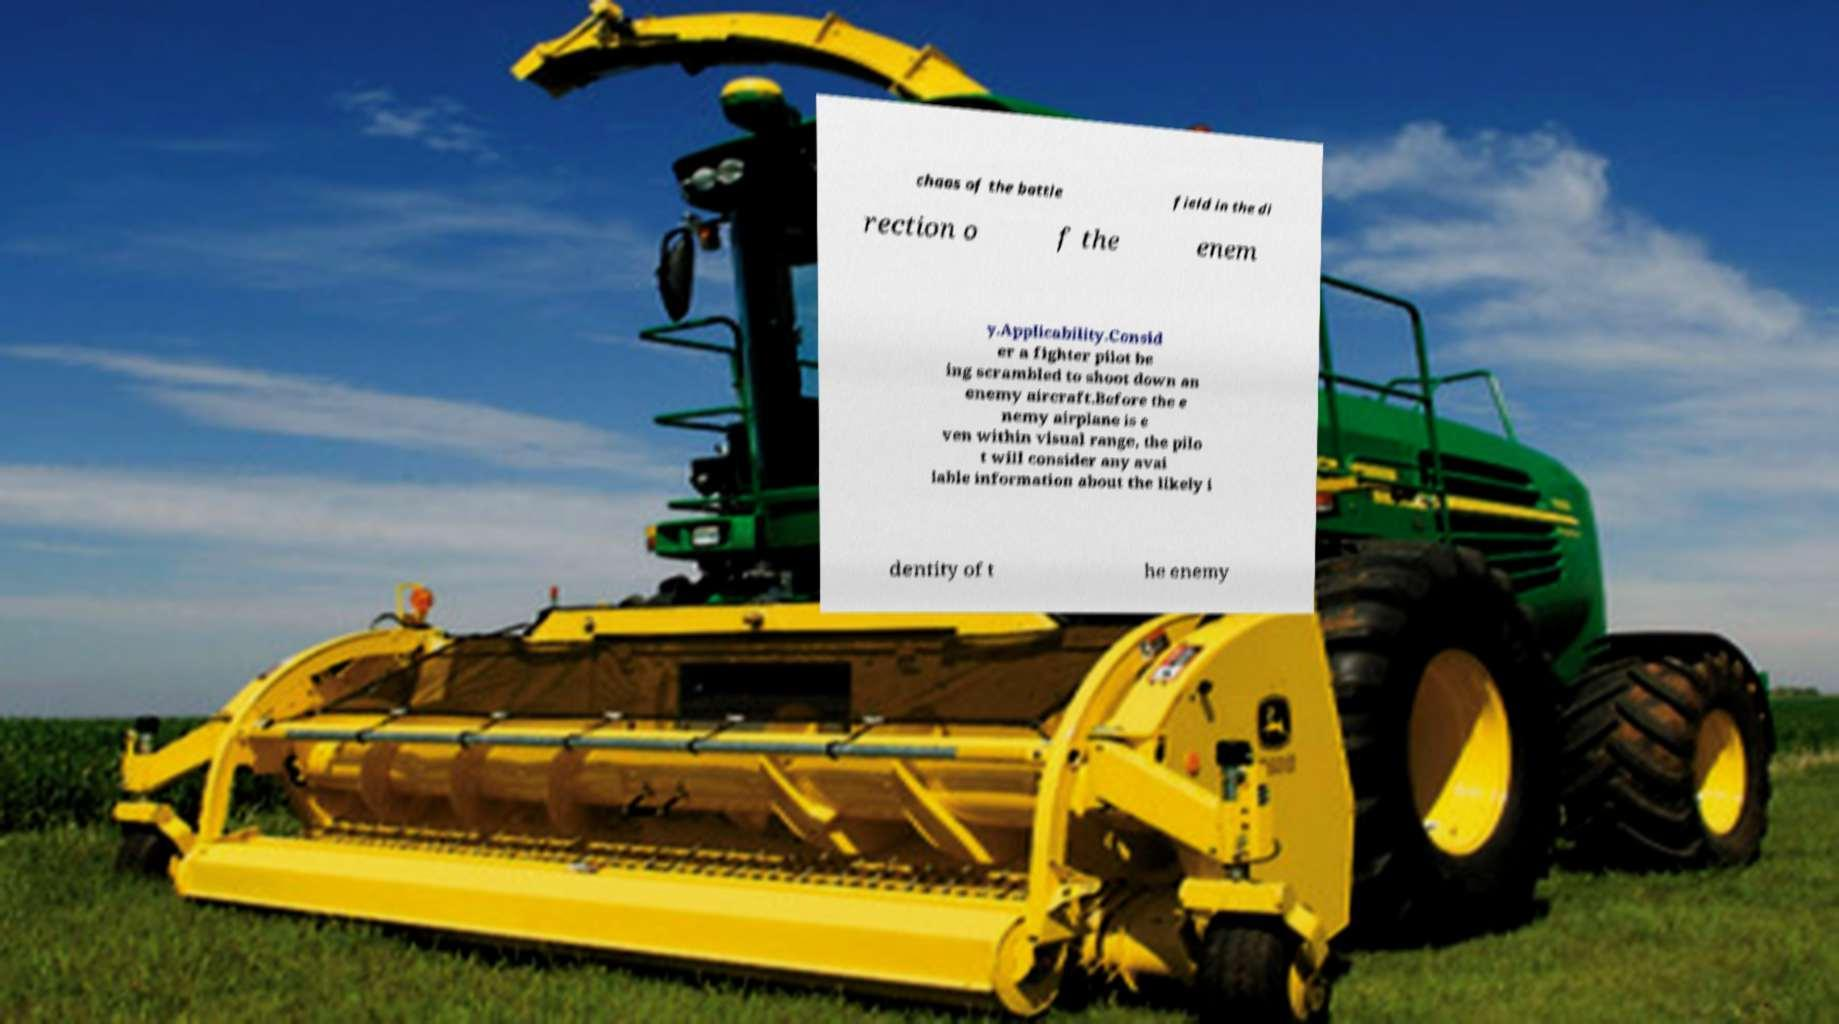For documentation purposes, I need the text within this image transcribed. Could you provide that? chaos of the battle field in the di rection o f the enem y.Applicability.Consid er a fighter pilot be ing scrambled to shoot down an enemy aircraft.Before the e nemy airplane is e ven within visual range, the pilo t will consider any avai lable information about the likely i dentity of t he enemy 